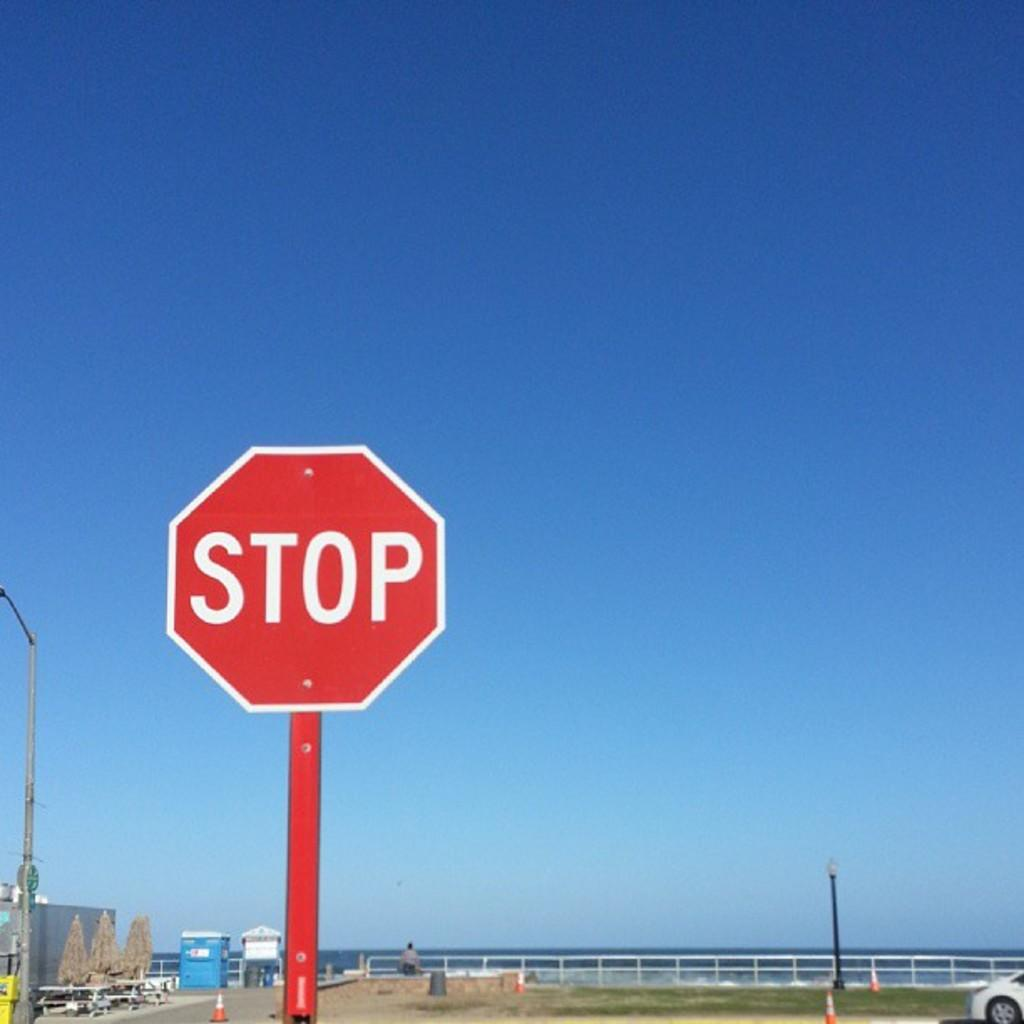<image>
Create a compact narrative representing the image presented. A red sign by a beach says Stop in white letters. 